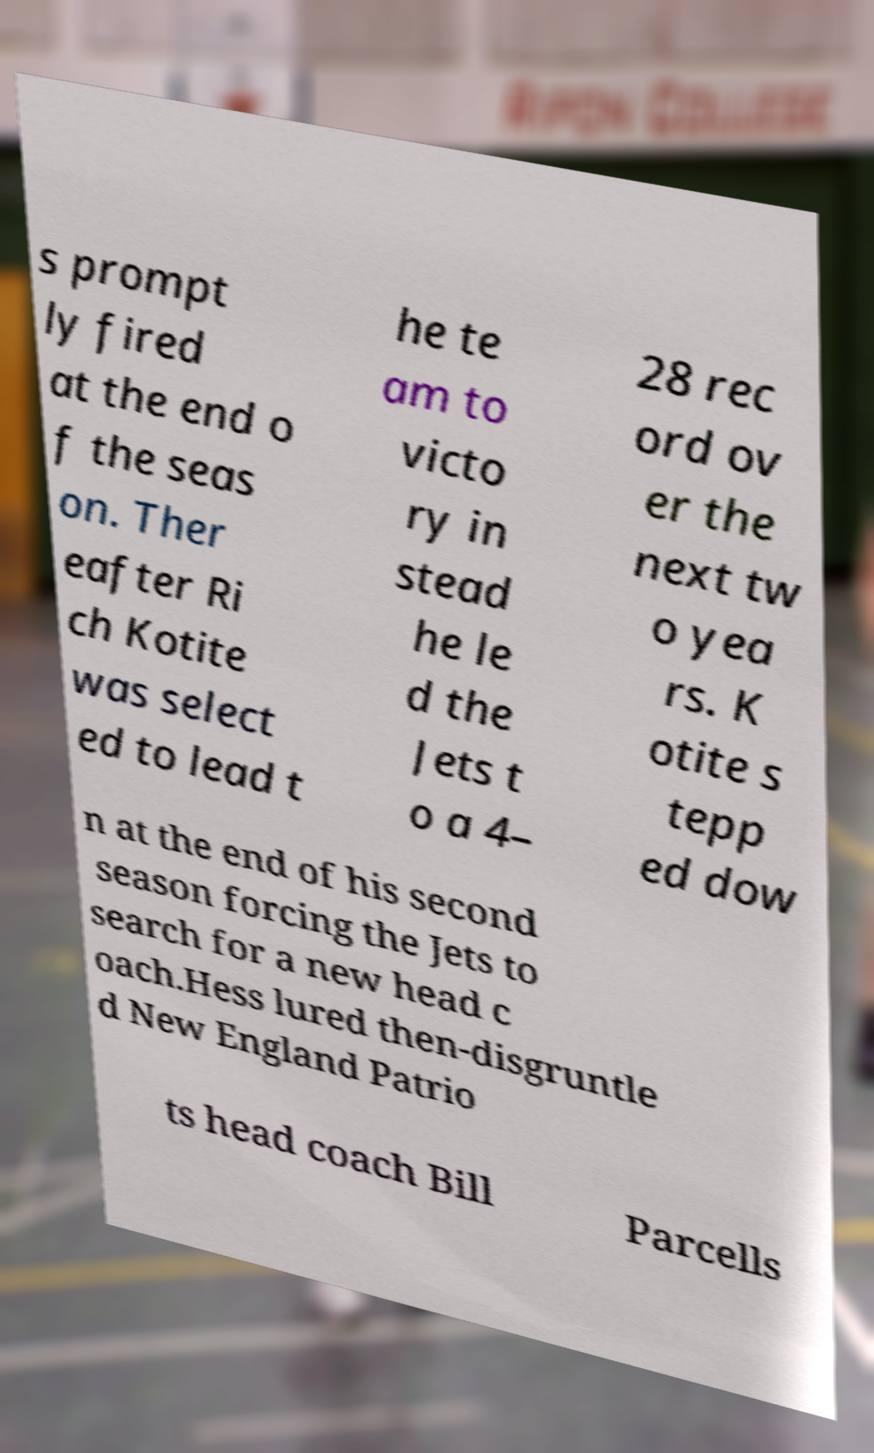Could you extract and type out the text from this image? s prompt ly fired at the end o f the seas on. Ther eafter Ri ch Kotite was select ed to lead t he te am to victo ry in stead he le d the Jets t o a 4– 28 rec ord ov er the next tw o yea rs. K otite s tepp ed dow n at the end of his second season forcing the Jets to search for a new head c oach.Hess lured then-disgruntle d New England Patrio ts head coach Bill Parcells 